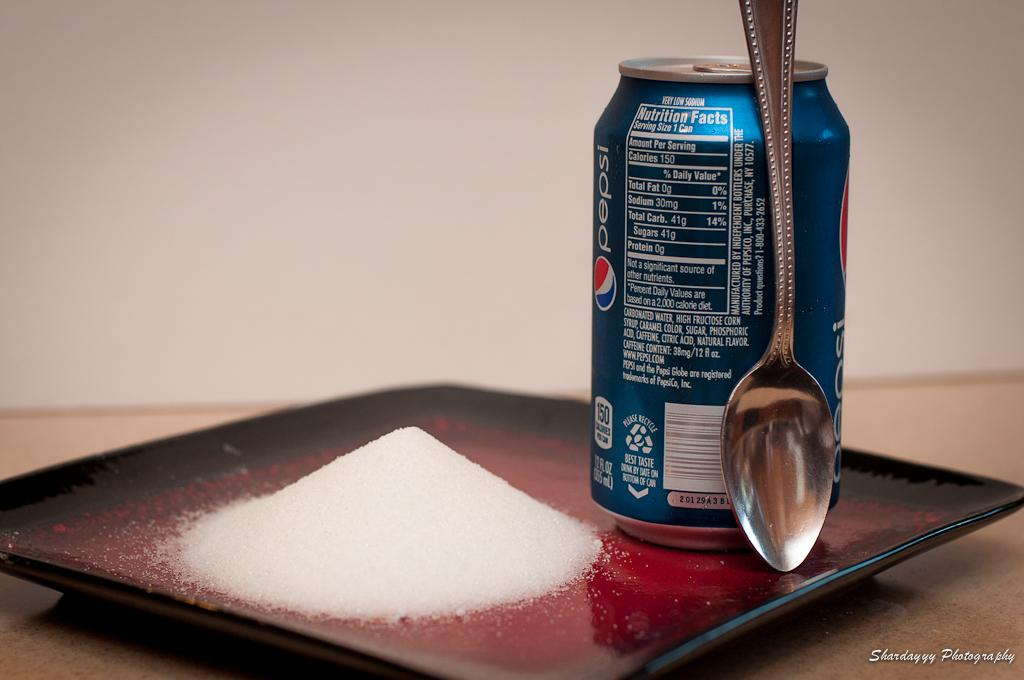<image>
Share a concise interpretation of the image provided. a plate with a spoon, pile of sugar, and Pepsi can 